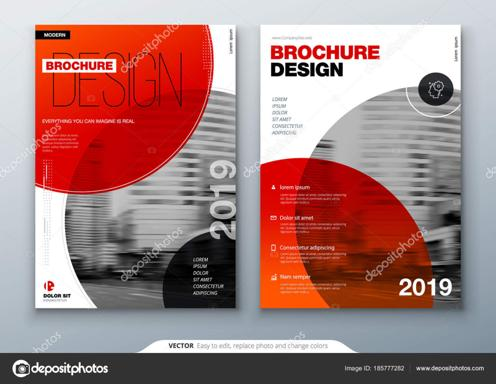Can you tell us more about the kind of businesses that might benefit from using this brochure design? This brochure design, with its contemporary layout and bold color scheme, specifically suits businesses in technology, consulting, or creative industries. These sectors typically favor modern and impactful marketing materials that can easily grab potential clients' attention. 